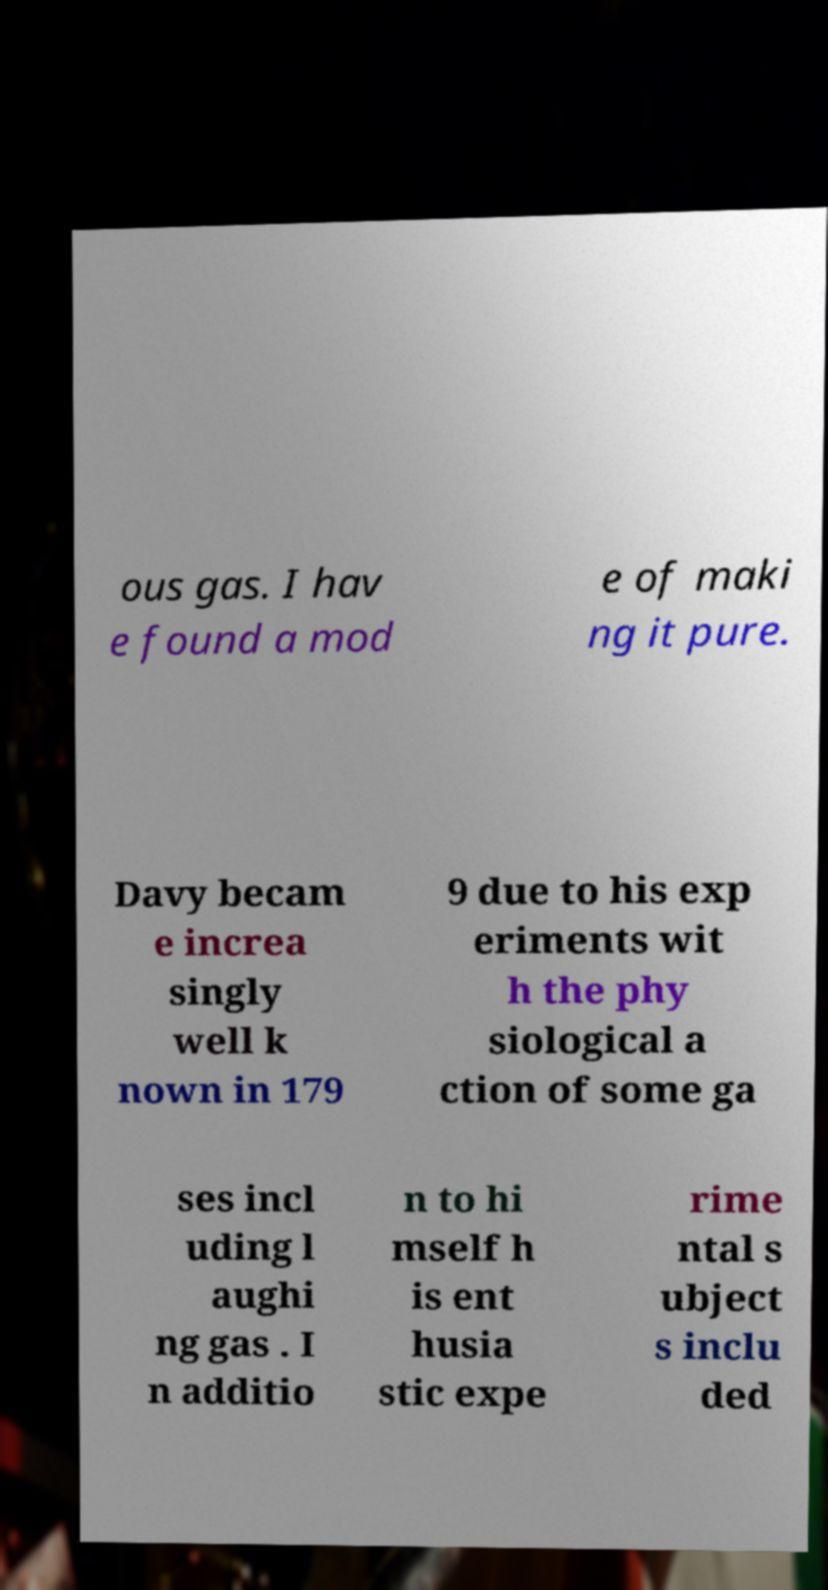Could you extract and type out the text from this image? ous gas. I hav e found a mod e of maki ng it pure. Davy becam e increa singly well k nown in 179 9 due to his exp eriments wit h the phy siological a ction of some ga ses incl uding l aughi ng gas . I n additio n to hi mself h is ent husia stic expe rime ntal s ubject s inclu ded 